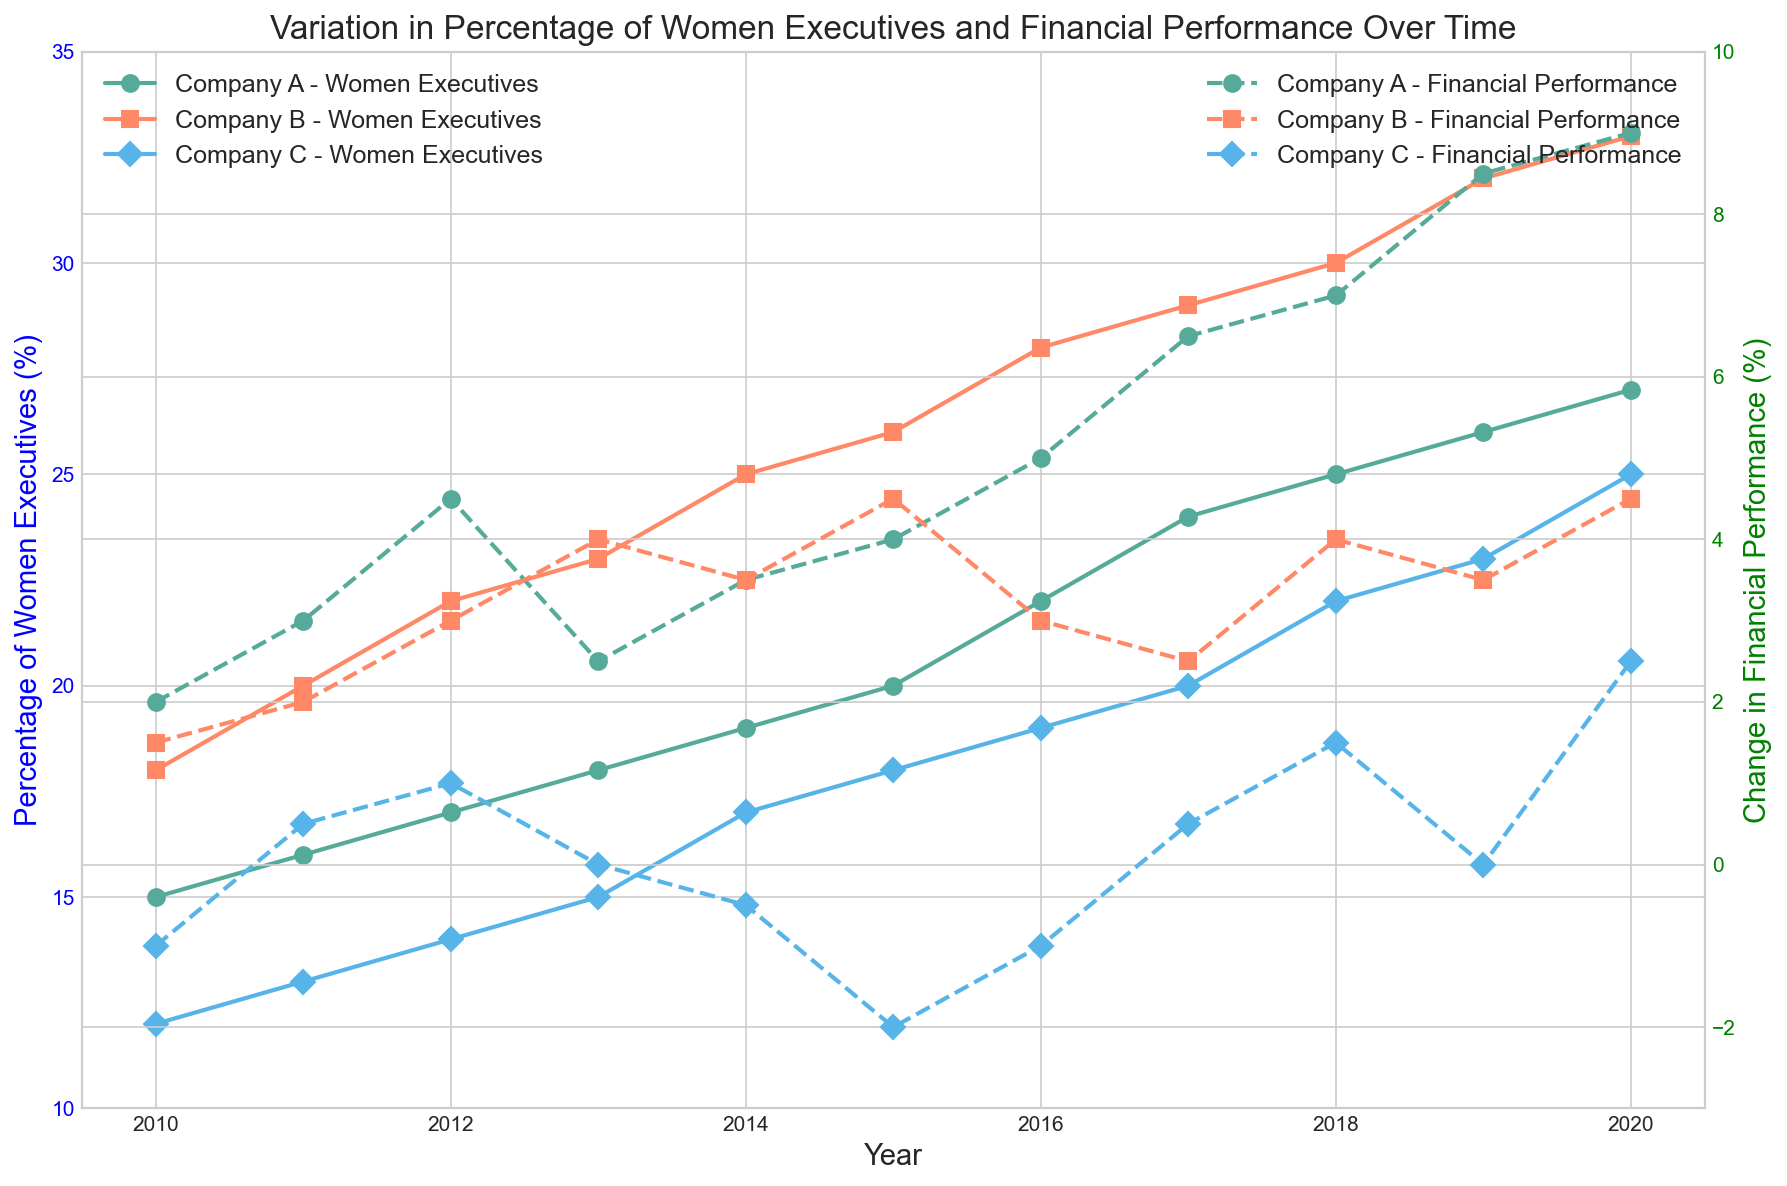What's the percentage of women executives in Company A in 2015 and 2019? To find the percentage of women executives in Company A for the years 2015 and 2019, refer to the blue line with circles for Company A. In 2015, it intersects at 20%. In 2019, it intersects at 26%.
Answer: 20% and 26% How did the financial performance of Company B change from 2015 to 2020? To determine the change in financial performance of Company B, look at the green line with squares for the years 2015 and 2020. In 2015, the performance change is 4.5%, and in 2020, it is 4.5%, indicating no change over these years.
Answer: No change Which company had the highest percentage increase in women executives from 2010 to 2020? Check the starting and ending points of the lines for each company from 2010 to 2020. Company A increased from 15% to 27%, Company B from 18% to 33%, and Company C from 12% to 25%. The highest increase is by Company B, from 18% to 33%.
Answer: Company B Compare the financial performance percentage changes in 2014 for Company A and Company C For the year 2014, Company A is represented by the green dashed line with circles intersecting at 3.5%, whereas Company C intersects at -0.5%. Company A shows a higher change in financial performance.
Answer: Company A had a higher change Which company experienced a negative change in financial performance in 2015, and what was the value? Look at the green dashed lines for 2015. Company C's line intersects at -2.0%, indicating a negative change. Both other companies (A and B) have positive changes.
Answer: Company C, -2.0% Over which years did Company C show a zero or negative change in financial performance? Look at the green dashed line with diamonds for Company C. Zero or negative changes are at 2010 (-1.0%), 2013 (0.0%), 2014 (-0.5%), 2015 (-2.0%), and 2016 (-1.0%).
Answer: 2010, 2013, 2014, 2015, 2016 What was the average percentage of women executives for Company B in 2018 and 2020? The percentages for Company B in 2018 and 2020 are 30% and 33% respectively. The average is (30 + 33) / 2 = 31.5%.
Answer: 31.5% Between 2012 and 2014, by how much did Company A's percentage of women executives increase? From 2012 to 2014, Company A's percentage of women executives increased from 17% to 19%. The increase amount is calculated as 19 - 17 = 2%.
Answer: 2% What is the visual difference in the trend lines for financial performance for Company A and Company B? The green dashed line with circles for Company A shows an overall upward trend from 2.0% to 9.0%, while the green dashed line with squares for Company B shows occasional fluctuations but overall a steady positive trend with a smaller increase from 1.5% to 4.5%.
Answer: Company A's trend has a stronger increasing pattern 